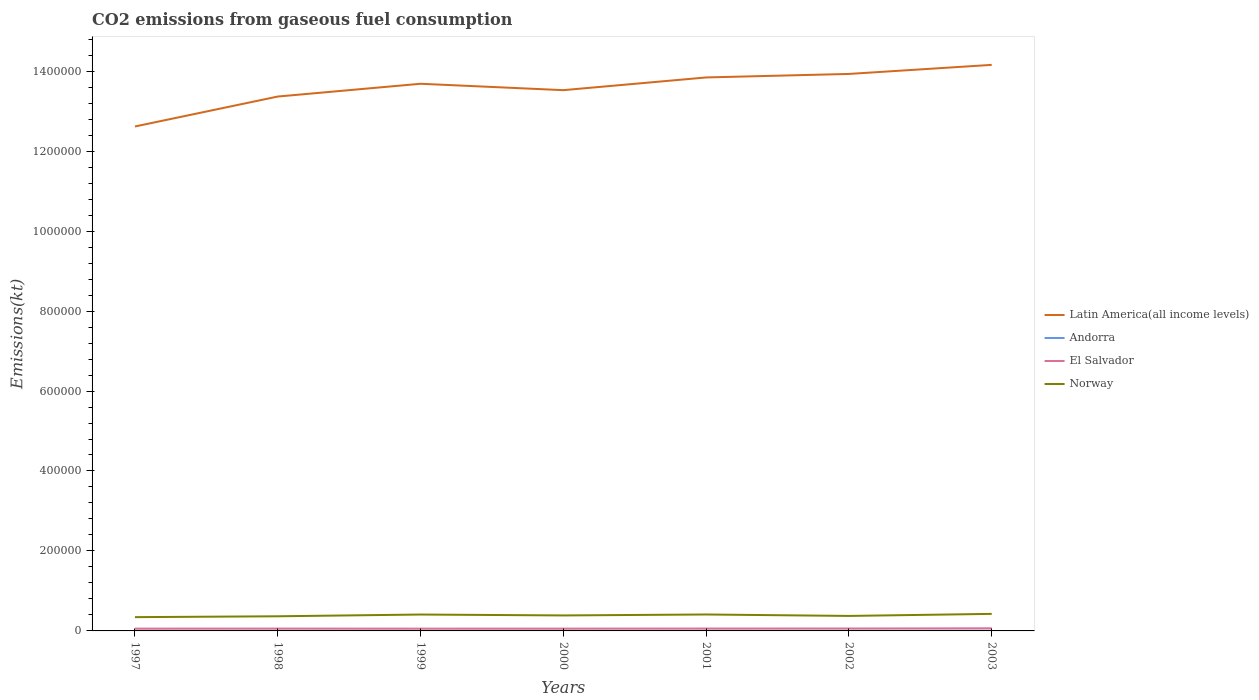Is the number of lines equal to the number of legend labels?
Your response must be concise. Yes. Across all years, what is the maximum amount of CO2 emitted in Norway?
Your response must be concise. 3.45e+04. What is the total amount of CO2 emitted in Latin America(all income levels) in the graph?
Offer a very short reply. -3.14e+04. What is the difference between the highest and the second highest amount of CO2 emitted in Norway?
Offer a terse response. 8166.41. What is the difference between the highest and the lowest amount of CO2 emitted in Latin America(all income levels)?
Your answer should be very brief. 4. How many years are there in the graph?
Ensure brevity in your answer.  7. What is the difference between two consecutive major ticks on the Y-axis?
Offer a terse response. 2.00e+05. Are the values on the major ticks of Y-axis written in scientific E-notation?
Provide a succinct answer. No. Does the graph contain grids?
Make the answer very short. No. What is the title of the graph?
Give a very brief answer. CO2 emissions from gaseous fuel consumption. Does "Netherlands" appear as one of the legend labels in the graph?
Give a very brief answer. No. What is the label or title of the Y-axis?
Give a very brief answer. Emissions(kt). What is the Emissions(kt) in Latin America(all income levels) in 1997?
Give a very brief answer. 1.26e+06. What is the Emissions(kt) in Andorra in 1997?
Ensure brevity in your answer.  458.38. What is the Emissions(kt) in El Salvador in 1997?
Give a very brief answer. 5760.86. What is the Emissions(kt) in Norway in 1997?
Provide a short and direct response. 3.45e+04. What is the Emissions(kt) of Latin America(all income levels) in 1998?
Provide a short and direct response. 1.34e+06. What is the Emissions(kt) in Andorra in 1998?
Keep it short and to the point. 484.04. What is the Emissions(kt) in El Salvador in 1998?
Offer a very short reply. 5812.19. What is the Emissions(kt) in Norway in 1998?
Give a very brief answer. 3.66e+04. What is the Emissions(kt) of Latin America(all income levels) in 1999?
Your response must be concise. 1.37e+06. What is the Emissions(kt) of Andorra in 1999?
Make the answer very short. 513.38. What is the Emissions(kt) of El Salvador in 1999?
Your response must be concise. 5698.52. What is the Emissions(kt) in Norway in 1999?
Provide a succinct answer. 4.10e+04. What is the Emissions(kt) of Latin America(all income levels) in 2000?
Give a very brief answer. 1.35e+06. What is the Emissions(kt) of Andorra in 2000?
Your response must be concise. 524.38. What is the Emissions(kt) of El Salvador in 2000?
Ensure brevity in your answer.  5742.52. What is the Emissions(kt) of Norway in 2000?
Keep it short and to the point. 3.87e+04. What is the Emissions(kt) in Latin America(all income levels) in 2001?
Your response must be concise. 1.38e+06. What is the Emissions(kt) of Andorra in 2001?
Offer a terse response. 524.38. What is the Emissions(kt) of El Salvador in 2001?
Give a very brief answer. 5947.87. What is the Emissions(kt) in Norway in 2001?
Your answer should be compact. 4.11e+04. What is the Emissions(kt) of Latin America(all income levels) in 2002?
Provide a short and direct response. 1.39e+06. What is the Emissions(kt) in Andorra in 2002?
Your answer should be compact. 531.72. What is the Emissions(kt) of El Salvador in 2002?
Make the answer very short. 6039.55. What is the Emissions(kt) of Norway in 2002?
Your answer should be very brief. 3.75e+04. What is the Emissions(kt) of Latin America(all income levels) in 2003?
Ensure brevity in your answer.  1.42e+06. What is the Emissions(kt) of Andorra in 2003?
Provide a short and direct response. 535.38. What is the Emissions(kt) of El Salvador in 2003?
Offer a terse response. 6552.93. What is the Emissions(kt) in Norway in 2003?
Provide a short and direct response. 4.26e+04. Across all years, what is the maximum Emissions(kt) of Latin America(all income levels)?
Keep it short and to the point. 1.42e+06. Across all years, what is the maximum Emissions(kt) in Andorra?
Ensure brevity in your answer.  535.38. Across all years, what is the maximum Emissions(kt) of El Salvador?
Provide a succinct answer. 6552.93. Across all years, what is the maximum Emissions(kt) in Norway?
Offer a very short reply. 4.26e+04. Across all years, what is the minimum Emissions(kt) in Latin America(all income levels)?
Your response must be concise. 1.26e+06. Across all years, what is the minimum Emissions(kt) in Andorra?
Make the answer very short. 458.38. Across all years, what is the minimum Emissions(kt) of El Salvador?
Your answer should be very brief. 5698.52. Across all years, what is the minimum Emissions(kt) of Norway?
Your answer should be compact. 3.45e+04. What is the total Emissions(kt) of Latin America(all income levels) in the graph?
Provide a succinct answer. 9.51e+06. What is the total Emissions(kt) in Andorra in the graph?
Your answer should be compact. 3571.66. What is the total Emissions(kt) in El Salvador in the graph?
Provide a succinct answer. 4.16e+04. What is the total Emissions(kt) of Norway in the graph?
Offer a very short reply. 2.72e+05. What is the difference between the Emissions(kt) in Latin America(all income levels) in 1997 and that in 1998?
Give a very brief answer. -7.49e+04. What is the difference between the Emissions(kt) in Andorra in 1997 and that in 1998?
Offer a very short reply. -25.67. What is the difference between the Emissions(kt) in El Salvador in 1997 and that in 1998?
Your answer should be compact. -51.34. What is the difference between the Emissions(kt) of Norway in 1997 and that in 1998?
Your answer should be compact. -2152.53. What is the difference between the Emissions(kt) of Latin America(all income levels) in 1997 and that in 1999?
Ensure brevity in your answer.  -1.07e+05. What is the difference between the Emissions(kt) in Andorra in 1997 and that in 1999?
Provide a succinct answer. -55.01. What is the difference between the Emissions(kt) of El Salvador in 1997 and that in 1999?
Ensure brevity in your answer.  62.34. What is the difference between the Emissions(kt) in Norway in 1997 and that in 1999?
Make the answer very short. -6512.59. What is the difference between the Emissions(kt) of Latin America(all income levels) in 1997 and that in 2000?
Give a very brief answer. -9.09e+04. What is the difference between the Emissions(kt) of Andorra in 1997 and that in 2000?
Your answer should be very brief. -66.01. What is the difference between the Emissions(kt) of El Salvador in 1997 and that in 2000?
Provide a succinct answer. 18.34. What is the difference between the Emissions(kt) in Norway in 1997 and that in 2000?
Provide a short and direct response. -4264.72. What is the difference between the Emissions(kt) of Latin America(all income levels) in 1997 and that in 2001?
Offer a very short reply. -1.23e+05. What is the difference between the Emissions(kt) in Andorra in 1997 and that in 2001?
Give a very brief answer. -66.01. What is the difference between the Emissions(kt) of El Salvador in 1997 and that in 2001?
Your answer should be compact. -187.02. What is the difference between the Emissions(kt) of Norway in 1997 and that in 2001?
Provide a short and direct response. -6662.94. What is the difference between the Emissions(kt) in Latin America(all income levels) in 1997 and that in 2002?
Provide a succinct answer. -1.31e+05. What is the difference between the Emissions(kt) of Andorra in 1997 and that in 2002?
Your answer should be very brief. -73.34. What is the difference between the Emissions(kt) in El Salvador in 1997 and that in 2002?
Provide a succinct answer. -278.69. What is the difference between the Emissions(kt) of Norway in 1997 and that in 2002?
Make the answer very short. -3028.94. What is the difference between the Emissions(kt) in Latin America(all income levels) in 1997 and that in 2003?
Offer a terse response. -1.54e+05. What is the difference between the Emissions(kt) in Andorra in 1997 and that in 2003?
Give a very brief answer. -77.01. What is the difference between the Emissions(kt) in El Salvador in 1997 and that in 2003?
Provide a short and direct response. -792.07. What is the difference between the Emissions(kt) in Norway in 1997 and that in 2003?
Give a very brief answer. -8166.41. What is the difference between the Emissions(kt) of Latin America(all income levels) in 1998 and that in 1999?
Your answer should be very brief. -3.19e+04. What is the difference between the Emissions(kt) of Andorra in 1998 and that in 1999?
Keep it short and to the point. -29.34. What is the difference between the Emissions(kt) in El Salvador in 1998 and that in 1999?
Give a very brief answer. 113.68. What is the difference between the Emissions(kt) of Norway in 1998 and that in 1999?
Provide a succinct answer. -4360.06. What is the difference between the Emissions(kt) in Latin America(all income levels) in 1998 and that in 2000?
Give a very brief answer. -1.60e+04. What is the difference between the Emissions(kt) in Andorra in 1998 and that in 2000?
Your answer should be compact. -40.34. What is the difference between the Emissions(kt) in El Salvador in 1998 and that in 2000?
Your answer should be very brief. 69.67. What is the difference between the Emissions(kt) of Norway in 1998 and that in 2000?
Keep it short and to the point. -2112.19. What is the difference between the Emissions(kt) in Latin America(all income levels) in 1998 and that in 2001?
Offer a terse response. -4.78e+04. What is the difference between the Emissions(kt) in Andorra in 1998 and that in 2001?
Your response must be concise. -40.34. What is the difference between the Emissions(kt) of El Salvador in 1998 and that in 2001?
Your response must be concise. -135.68. What is the difference between the Emissions(kt) in Norway in 1998 and that in 2001?
Ensure brevity in your answer.  -4510.41. What is the difference between the Emissions(kt) in Latin America(all income levels) in 1998 and that in 2002?
Offer a very short reply. -5.65e+04. What is the difference between the Emissions(kt) of Andorra in 1998 and that in 2002?
Your response must be concise. -47.67. What is the difference between the Emissions(kt) in El Salvador in 1998 and that in 2002?
Your answer should be very brief. -227.35. What is the difference between the Emissions(kt) of Norway in 1998 and that in 2002?
Give a very brief answer. -876.41. What is the difference between the Emissions(kt) of Latin America(all income levels) in 1998 and that in 2003?
Your answer should be very brief. -7.92e+04. What is the difference between the Emissions(kt) in Andorra in 1998 and that in 2003?
Offer a very short reply. -51.34. What is the difference between the Emissions(kt) of El Salvador in 1998 and that in 2003?
Offer a very short reply. -740.73. What is the difference between the Emissions(kt) in Norway in 1998 and that in 2003?
Give a very brief answer. -6013.88. What is the difference between the Emissions(kt) of Latin America(all income levels) in 1999 and that in 2000?
Offer a terse response. 1.60e+04. What is the difference between the Emissions(kt) in Andorra in 1999 and that in 2000?
Ensure brevity in your answer.  -11. What is the difference between the Emissions(kt) in El Salvador in 1999 and that in 2000?
Ensure brevity in your answer.  -44. What is the difference between the Emissions(kt) of Norway in 1999 and that in 2000?
Ensure brevity in your answer.  2247.87. What is the difference between the Emissions(kt) in Latin America(all income levels) in 1999 and that in 2001?
Offer a terse response. -1.58e+04. What is the difference between the Emissions(kt) of Andorra in 1999 and that in 2001?
Give a very brief answer. -11. What is the difference between the Emissions(kt) of El Salvador in 1999 and that in 2001?
Give a very brief answer. -249.36. What is the difference between the Emissions(kt) of Norway in 1999 and that in 2001?
Ensure brevity in your answer.  -150.35. What is the difference between the Emissions(kt) of Latin America(all income levels) in 1999 and that in 2002?
Offer a terse response. -2.46e+04. What is the difference between the Emissions(kt) of Andorra in 1999 and that in 2002?
Your answer should be very brief. -18.34. What is the difference between the Emissions(kt) of El Salvador in 1999 and that in 2002?
Your answer should be very brief. -341.03. What is the difference between the Emissions(kt) in Norway in 1999 and that in 2002?
Provide a short and direct response. 3483.65. What is the difference between the Emissions(kt) of Latin America(all income levels) in 1999 and that in 2003?
Offer a very short reply. -4.73e+04. What is the difference between the Emissions(kt) of Andorra in 1999 and that in 2003?
Your response must be concise. -22. What is the difference between the Emissions(kt) in El Salvador in 1999 and that in 2003?
Provide a succinct answer. -854.41. What is the difference between the Emissions(kt) of Norway in 1999 and that in 2003?
Your answer should be very brief. -1653.82. What is the difference between the Emissions(kt) of Latin America(all income levels) in 2000 and that in 2001?
Your answer should be very brief. -3.18e+04. What is the difference between the Emissions(kt) in El Salvador in 2000 and that in 2001?
Keep it short and to the point. -205.35. What is the difference between the Emissions(kt) in Norway in 2000 and that in 2001?
Provide a short and direct response. -2398.22. What is the difference between the Emissions(kt) of Latin America(all income levels) in 2000 and that in 2002?
Offer a terse response. -4.06e+04. What is the difference between the Emissions(kt) in Andorra in 2000 and that in 2002?
Your response must be concise. -7.33. What is the difference between the Emissions(kt) in El Salvador in 2000 and that in 2002?
Ensure brevity in your answer.  -297.03. What is the difference between the Emissions(kt) in Norway in 2000 and that in 2002?
Your answer should be very brief. 1235.78. What is the difference between the Emissions(kt) of Latin America(all income levels) in 2000 and that in 2003?
Provide a succinct answer. -6.32e+04. What is the difference between the Emissions(kt) in Andorra in 2000 and that in 2003?
Give a very brief answer. -11. What is the difference between the Emissions(kt) of El Salvador in 2000 and that in 2003?
Offer a very short reply. -810.41. What is the difference between the Emissions(kt) in Norway in 2000 and that in 2003?
Make the answer very short. -3901.69. What is the difference between the Emissions(kt) in Latin America(all income levels) in 2001 and that in 2002?
Ensure brevity in your answer.  -8783.15. What is the difference between the Emissions(kt) of Andorra in 2001 and that in 2002?
Provide a short and direct response. -7.33. What is the difference between the Emissions(kt) of El Salvador in 2001 and that in 2002?
Provide a succinct answer. -91.67. What is the difference between the Emissions(kt) of Norway in 2001 and that in 2002?
Your answer should be very brief. 3634. What is the difference between the Emissions(kt) of Latin America(all income levels) in 2001 and that in 2003?
Give a very brief answer. -3.14e+04. What is the difference between the Emissions(kt) of Andorra in 2001 and that in 2003?
Keep it short and to the point. -11. What is the difference between the Emissions(kt) of El Salvador in 2001 and that in 2003?
Make the answer very short. -605.05. What is the difference between the Emissions(kt) of Norway in 2001 and that in 2003?
Provide a succinct answer. -1503.47. What is the difference between the Emissions(kt) in Latin America(all income levels) in 2002 and that in 2003?
Ensure brevity in your answer.  -2.27e+04. What is the difference between the Emissions(kt) of Andorra in 2002 and that in 2003?
Ensure brevity in your answer.  -3.67. What is the difference between the Emissions(kt) in El Salvador in 2002 and that in 2003?
Ensure brevity in your answer.  -513.38. What is the difference between the Emissions(kt) in Norway in 2002 and that in 2003?
Make the answer very short. -5137.47. What is the difference between the Emissions(kt) in Latin America(all income levels) in 1997 and the Emissions(kt) in Andorra in 1998?
Make the answer very short. 1.26e+06. What is the difference between the Emissions(kt) in Latin America(all income levels) in 1997 and the Emissions(kt) in El Salvador in 1998?
Provide a short and direct response. 1.26e+06. What is the difference between the Emissions(kt) of Latin America(all income levels) in 1997 and the Emissions(kt) of Norway in 1998?
Offer a very short reply. 1.23e+06. What is the difference between the Emissions(kt) in Andorra in 1997 and the Emissions(kt) in El Salvador in 1998?
Your response must be concise. -5353.82. What is the difference between the Emissions(kt) of Andorra in 1997 and the Emissions(kt) of Norway in 1998?
Your answer should be compact. -3.62e+04. What is the difference between the Emissions(kt) in El Salvador in 1997 and the Emissions(kt) in Norway in 1998?
Your response must be concise. -3.09e+04. What is the difference between the Emissions(kt) in Latin America(all income levels) in 1997 and the Emissions(kt) in Andorra in 1999?
Give a very brief answer. 1.26e+06. What is the difference between the Emissions(kt) of Latin America(all income levels) in 1997 and the Emissions(kt) of El Salvador in 1999?
Keep it short and to the point. 1.26e+06. What is the difference between the Emissions(kt) in Latin America(all income levels) in 1997 and the Emissions(kt) in Norway in 1999?
Ensure brevity in your answer.  1.22e+06. What is the difference between the Emissions(kt) of Andorra in 1997 and the Emissions(kt) of El Salvador in 1999?
Offer a terse response. -5240.14. What is the difference between the Emissions(kt) of Andorra in 1997 and the Emissions(kt) of Norway in 1999?
Provide a succinct answer. -4.05e+04. What is the difference between the Emissions(kt) in El Salvador in 1997 and the Emissions(kt) in Norway in 1999?
Your answer should be compact. -3.52e+04. What is the difference between the Emissions(kt) of Latin America(all income levels) in 1997 and the Emissions(kt) of Andorra in 2000?
Offer a very short reply. 1.26e+06. What is the difference between the Emissions(kt) of Latin America(all income levels) in 1997 and the Emissions(kt) of El Salvador in 2000?
Your answer should be very brief. 1.26e+06. What is the difference between the Emissions(kt) of Latin America(all income levels) in 1997 and the Emissions(kt) of Norway in 2000?
Ensure brevity in your answer.  1.22e+06. What is the difference between the Emissions(kt) in Andorra in 1997 and the Emissions(kt) in El Salvador in 2000?
Make the answer very short. -5284.15. What is the difference between the Emissions(kt) in Andorra in 1997 and the Emissions(kt) in Norway in 2000?
Give a very brief answer. -3.83e+04. What is the difference between the Emissions(kt) of El Salvador in 1997 and the Emissions(kt) of Norway in 2000?
Ensure brevity in your answer.  -3.30e+04. What is the difference between the Emissions(kt) in Latin America(all income levels) in 1997 and the Emissions(kt) in Andorra in 2001?
Your answer should be compact. 1.26e+06. What is the difference between the Emissions(kt) of Latin America(all income levels) in 1997 and the Emissions(kt) of El Salvador in 2001?
Your response must be concise. 1.26e+06. What is the difference between the Emissions(kt) of Latin America(all income levels) in 1997 and the Emissions(kt) of Norway in 2001?
Provide a succinct answer. 1.22e+06. What is the difference between the Emissions(kt) in Andorra in 1997 and the Emissions(kt) in El Salvador in 2001?
Your answer should be compact. -5489.5. What is the difference between the Emissions(kt) in Andorra in 1997 and the Emissions(kt) in Norway in 2001?
Your answer should be very brief. -4.07e+04. What is the difference between the Emissions(kt) in El Salvador in 1997 and the Emissions(kt) in Norway in 2001?
Provide a succinct answer. -3.54e+04. What is the difference between the Emissions(kt) in Latin America(all income levels) in 1997 and the Emissions(kt) in Andorra in 2002?
Offer a very short reply. 1.26e+06. What is the difference between the Emissions(kt) of Latin America(all income levels) in 1997 and the Emissions(kt) of El Salvador in 2002?
Make the answer very short. 1.26e+06. What is the difference between the Emissions(kt) in Latin America(all income levels) in 1997 and the Emissions(kt) in Norway in 2002?
Offer a terse response. 1.22e+06. What is the difference between the Emissions(kt) in Andorra in 1997 and the Emissions(kt) in El Salvador in 2002?
Your answer should be very brief. -5581.17. What is the difference between the Emissions(kt) of Andorra in 1997 and the Emissions(kt) of Norway in 2002?
Provide a succinct answer. -3.70e+04. What is the difference between the Emissions(kt) in El Salvador in 1997 and the Emissions(kt) in Norway in 2002?
Your answer should be very brief. -3.17e+04. What is the difference between the Emissions(kt) of Latin America(all income levels) in 1997 and the Emissions(kt) of Andorra in 2003?
Offer a very short reply. 1.26e+06. What is the difference between the Emissions(kt) in Latin America(all income levels) in 1997 and the Emissions(kt) in El Salvador in 2003?
Provide a short and direct response. 1.26e+06. What is the difference between the Emissions(kt) in Latin America(all income levels) in 1997 and the Emissions(kt) in Norway in 2003?
Offer a very short reply. 1.22e+06. What is the difference between the Emissions(kt) in Andorra in 1997 and the Emissions(kt) in El Salvador in 2003?
Give a very brief answer. -6094.55. What is the difference between the Emissions(kt) in Andorra in 1997 and the Emissions(kt) in Norway in 2003?
Make the answer very short. -4.22e+04. What is the difference between the Emissions(kt) in El Salvador in 1997 and the Emissions(kt) in Norway in 2003?
Make the answer very short. -3.69e+04. What is the difference between the Emissions(kt) in Latin America(all income levels) in 1998 and the Emissions(kt) in Andorra in 1999?
Offer a terse response. 1.34e+06. What is the difference between the Emissions(kt) in Latin America(all income levels) in 1998 and the Emissions(kt) in El Salvador in 1999?
Ensure brevity in your answer.  1.33e+06. What is the difference between the Emissions(kt) in Latin America(all income levels) in 1998 and the Emissions(kt) in Norway in 1999?
Offer a terse response. 1.30e+06. What is the difference between the Emissions(kt) of Andorra in 1998 and the Emissions(kt) of El Salvador in 1999?
Provide a succinct answer. -5214.47. What is the difference between the Emissions(kt) in Andorra in 1998 and the Emissions(kt) in Norway in 1999?
Keep it short and to the point. -4.05e+04. What is the difference between the Emissions(kt) in El Salvador in 1998 and the Emissions(kt) in Norway in 1999?
Your answer should be compact. -3.52e+04. What is the difference between the Emissions(kt) in Latin America(all income levels) in 1998 and the Emissions(kt) in Andorra in 2000?
Your response must be concise. 1.34e+06. What is the difference between the Emissions(kt) of Latin America(all income levels) in 1998 and the Emissions(kt) of El Salvador in 2000?
Offer a very short reply. 1.33e+06. What is the difference between the Emissions(kt) in Latin America(all income levels) in 1998 and the Emissions(kt) in Norway in 2000?
Ensure brevity in your answer.  1.30e+06. What is the difference between the Emissions(kt) of Andorra in 1998 and the Emissions(kt) of El Salvador in 2000?
Ensure brevity in your answer.  -5258.48. What is the difference between the Emissions(kt) in Andorra in 1998 and the Emissions(kt) in Norway in 2000?
Ensure brevity in your answer.  -3.82e+04. What is the difference between the Emissions(kt) in El Salvador in 1998 and the Emissions(kt) in Norway in 2000?
Your response must be concise. -3.29e+04. What is the difference between the Emissions(kt) of Latin America(all income levels) in 1998 and the Emissions(kt) of Andorra in 2001?
Offer a very short reply. 1.34e+06. What is the difference between the Emissions(kt) in Latin America(all income levels) in 1998 and the Emissions(kt) in El Salvador in 2001?
Offer a terse response. 1.33e+06. What is the difference between the Emissions(kt) of Latin America(all income levels) in 1998 and the Emissions(kt) of Norway in 2001?
Offer a very short reply. 1.30e+06. What is the difference between the Emissions(kt) of Andorra in 1998 and the Emissions(kt) of El Salvador in 2001?
Give a very brief answer. -5463.83. What is the difference between the Emissions(kt) of Andorra in 1998 and the Emissions(kt) of Norway in 2001?
Offer a very short reply. -4.06e+04. What is the difference between the Emissions(kt) in El Salvador in 1998 and the Emissions(kt) in Norway in 2001?
Offer a very short reply. -3.53e+04. What is the difference between the Emissions(kt) in Latin America(all income levels) in 1998 and the Emissions(kt) in Andorra in 2002?
Provide a succinct answer. 1.34e+06. What is the difference between the Emissions(kt) in Latin America(all income levels) in 1998 and the Emissions(kt) in El Salvador in 2002?
Make the answer very short. 1.33e+06. What is the difference between the Emissions(kt) of Latin America(all income levels) in 1998 and the Emissions(kt) of Norway in 2002?
Provide a succinct answer. 1.30e+06. What is the difference between the Emissions(kt) of Andorra in 1998 and the Emissions(kt) of El Salvador in 2002?
Your answer should be compact. -5555.51. What is the difference between the Emissions(kt) of Andorra in 1998 and the Emissions(kt) of Norway in 2002?
Make the answer very short. -3.70e+04. What is the difference between the Emissions(kt) of El Salvador in 1998 and the Emissions(kt) of Norway in 2002?
Ensure brevity in your answer.  -3.17e+04. What is the difference between the Emissions(kt) of Latin America(all income levels) in 1998 and the Emissions(kt) of Andorra in 2003?
Provide a succinct answer. 1.34e+06. What is the difference between the Emissions(kt) in Latin America(all income levels) in 1998 and the Emissions(kt) in El Salvador in 2003?
Give a very brief answer. 1.33e+06. What is the difference between the Emissions(kt) in Latin America(all income levels) in 1998 and the Emissions(kt) in Norway in 2003?
Give a very brief answer. 1.29e+06. What is the difference between the Emissions(kt) in Andorra in 1998 and the Emissions(kt) in El Salvador in 2003?
Your response must be concise. -6068.89. What is the difference between the Emissions(kt) of Andorra in 1998 and the Emissions(kt) of Norway in 2003?
Your answer should be very brief. -4.21e+04. What is the difference between the Emissions(kt) of El Salvador in 1998 and the Emissions(kt) of Norway in 2003?
Provide a succinct answer. -3.68e+04. What is the difference between the Emissions(kt) in Latin America(all income levels) in 1999 and the Emissions(kt) in Andorra in 2000?
Give a very brief answer. 1.37e+06. What is the difference between the Emissions(kt) of Latin America(all income levels) in 1999 and the Emissions(kt) of El Salvador in 2000?
Give a very brief answer. 1.36e+06. What is the difference between the Emissions(kt) in Latin America(all income levels) in 1999 and the Emissions(kt) in Norway in 2000?
Provide a short and direct response. 1.33e+06. What is the difference between the Emissions(kt) of Andorra in 1999 and the Emissions(kt) of El Salvador in 2000?
Your answer should be very brief. -5229.14. What is the difference between the Emissions(kt) in Andorra in 1999 and the Emissions(kt) in Norway in 2000?
Offer a very short reply. -3.82e+04. What is the difference between the Emissions(kt) of El Salvador in 1999 and the Emissions(kt) of Norway in 2000?
Give a very brief answer. -3.30e+04. What is the difference between the Emissions(kt) in Latin America(all income levels) in 1999 and the Emissions(kt) in Andorra in 2001?
Keep it short and to the point. 1.37e+06. What is the difference between the Emissions(kt) of Latin America(all income levels) in 1999 and the Emissions(kt) of El Salvador in 2001?
Ensure brevity in your answer.  1.36e+06. What is the difference between the Emissions(kt) in Latin America(all income levels) in 1999 and the Emissions(kt) in Norway in 2001?
Provide a short and direct response. 1.33e+06. What is the difference between the Emissions(kt) of Andorra in 1999 and the Emissions(kt) of El Salvador in 2001?
Offer a very short reply. -5434.49. What is the difference between the Emissions(kt) of Andorra in 1999 and the Emissions(kt) of Norway in 2001?
Keep it short and to the point. -4.06e+04. What is the difference between the Emissions(kt) in El Salvador in 1999 and the Emissions(kt) in Norway in 2001?
Provide a succinct answer. -3.54e+04. What is the difference between the Emissions(kt) in Latin America(all income levels) in 1999 and the Emissions(kt) in Andorra in 2002?
Provide a succinct answer. 1.37e+06. What is the difference between the Emissions(kt) of Latin America(all income levels) in 1999 and the Emissions(kt) of El Salvador in 2002?
Give a very brief answer. 1.36e+06. What is the difference between the Emissions(kt) of Latin America(all income levels) in 1999 and the Emissions(kt) of Norway in 2002?
Offer a terse response. 1.33e+06. What is the difference between the Emissions(kt) in Andorra in 1999 and the Emissions(kt) in El Salvador in 2002?
Provide a succinct answer. -5526.17. What is the difference between the Emissions(kt) of Andorra in 1999 and the Emissions(kt) of Norway in 2002?
Make the answer very short. -3.70e+04. What is the difference between the Emissions(kt) in El Salvador in 1999 and the Emissions(kt) in Norway in 2002?
Give a very brief answer. -3.18e+04. What is the difference between the Emissions(kt) of Latin America(all income levels) in 1999 and the Emissions(kt) of Andorra in 2003?
Keep it short and to the point. 1.37e+06. What is the difference between the Emissions(kt) in Latin America(all income levels) in 1999 and the Emissions(kt) in El Salvador in 2003?
Your answer should be compact. 1.36e+06. What is the difference between the Emissions(kt) of Latin America(all income levels) in 1999 and the Emissions(kt) of Norway in 2003?
Ensure brevity in your answer.  1.33e+06. What is the difference between the Emissions(kt) in Andorra in 1999 and the Emissions(kt) in El Salvador in 2003?
Offer a very short reply. -6039.55. What is the difference between the Emissions(kt) in Andorra in 1999 and the Emissions(kt) in Norway in 2003?
Give a very brief answer. -4.21e+04. What is the difference between the Emissions(kt) in El Salvador in 1999 and the Emissions(kt) in Norway in 2003?
Your response must be concise. -3.69e+04. What is the difference between the Emissions(kt) in Latin America(all income levels) in 2000 and the Emissions(kt) in Andorra in 2001?
Give a very brief answer. 1.35e+06. What is the difference between the Emissions(kt) in Latin America(all income levels) in 2000 and the Emissions(kt) in El Salvador in 2001?
Your response must be concise. 1.35e+06. What is the difference between the Emissions(kt) of Latin America(all income levels) in 2000 and the Emissions(kt) of Norway in 2001?
Your response must be concise. 1.31e+06. What is the difference between the Emissions(kt) in Andorra in 2000 and the Emissions(kt) in El Salvador in 2001?
Offer a very short reply. -5423.49. What is the difference between the Emissions(kt) in Andorra in 2000 and the Emissions(kt) in Norway in 2001?
Your answer should be very brief. -4.06e+04. What is the difference between the Emissions(kt) in El Salvador in 2000 and the Emissions(kt) in Norway in 2001?
Keep it short and to the point. -3.54e+04. What is the difference between the Emissions(kt) in Latin America(all income levels) in 2000 and the Emissions(kt) in Andorra in 2002?
Provide a succinct answer. 1.35e+06. What is the difference between the Emissions(kt) of Latin America(all income levels) in 2000 and the Emissions(kt) of El Salvador in 2002?
Keep it short and to the point. 1.35e+06. What is the difference between the Emissions(kt) in Latin America(all income levels) in 2000 and the Emissions(kt) in Norway in 2002?
Offer a very short reply. 1.32e+06. What is the difference between the Emissions(kt) of Andorra in 2000 and the Emissions(kt) of El Salvador in 2002?
Give a very brief answer. -5515.17. What is the difference between the Emissions(kt) in Andorra in 2000 and the Emissions(kt) in Norway in 2002?
Provide a succinct answer. -3.70e+04. What is the difference between the Emissions(kt) of El Salvador in 2000 and the Emissions(kt) of Norway in 2002?
Your response must be concise. -3.18e+04. What is the difference between the Emissions(kt) of Latin America(all income levels) in 2000 and the Emissions(kt) of Andorra in 2003?
Provide a succinct answer. 1.35e+06. What is the difference between the Emissions(kt) in Latin America(all income levels) in 2000 and the Emissions(kt) in El Salvador in 2003?
Give a very brief answer. 1.35e+06. What is the difference between the Emissions(kt) in Latin America(all income levels) in 2000 and the Emissions(kt) in Norway in 2003?
Your answer should be very brief. 1.31e+06. What is the difference between the Emissions(kt) of Andorra in 2000 and the Emissions(kt) of El Salvador in 2003?
Offer a terse response. -6028.55. What is the difference between the Emissions(kt) in Andorra in 2000 and the Emissions(kt) in Norway in 2003?
Ensure brevity in your answer.  -4.21e+04. What is the difference between the Emissions(kt) of El Salvador in 2000 and the Emissions(kt) of Norway in 2003?
Give a very brief answer. -3.69e+04. What is the difference between the Emissions(kt) in Latin America(all income levels) in 2001 and the Emissions(kt) in Andorra in 2002?
Your answer should be very brief. 1.38e+06. What is the difference between the Emissions(kt) of Latin America(all income levels) in 2001 and the Emissions(kt) of El Salvador in 2002?
Offer a very short reply. 1.38e+06. What is the difference between the Emissions(kt) in Latin America(all income levels) in 2001 and the Emissions(kt) in Norway in 2002?
Your response must be concise. 1.35e+06. What is the difference between the Emissions(kt) of Andorra in 2001 and the Emissions(kt) of El Salvador in 2002?
Your response must be concise. -5515.17. What is the difference between the Emissions(kt) of Andorra in 2001 and the Emissions(kt) of Norway in 2002?
Your answer should be very brief. -3.70e+04. What is the difference between the Emissions(kt) in El Salvador in 2001 and the Emissions(kt) in Norway in 2002?
Provide a short and direct response. -3.15e+04. What is the difference between the Emissions(kt) of Latin America(all income levels) in 2001 and the Emissions(kt) of Andorra in 2003?
Your response must be concise. 1.38e+06. What is the difference between the Emissions(kt) of Latin America(all income levels) in 2001 and the Emissions(kt) of El Salvador in 2003?
Give a very brief answer. 1.38e+06. What is the difference between the Emissions(kt) in Latin America(all income levels) in 2001 and the Emissions(kt) in Norway in 2003?
Keep it short and to the point. 1.34e+06. What is the difference between the Emissions(kt) of Andorra in 2001 and the Emissions(kt) of El Salvador in 2003?
Offer a very short reply. -6028.55. What is the difference between the Emissions(kt) of Andorra in 2001 and the Emissions(kt) of Norway in 2003?
Offer a very short reply. -4.21e+04. What is the difference between the Emissions(kt) of El Salvador in 2001 and the Emissions(kt) of Norway in 2003?
Your answer should be compact. -3.67e+04. What is the difference between the Emissions(kt) in Latin America(all income levels) in 2002 and the Emissions(kt) in Andorra in 2003?
Offer a terse response. 1.39e+06. What is the difference between the Emissions(kt) of Latin America(all income levels) in 2002 and the Emissions(kt) of El Salvador in 2003?
Provide a succinct answer. 1.39e+06. What is the difference between the Emissions(kt) in Latin America(all income levels) in 2002 and the Emissions(kt) in Norway in 2003?
Provide a succinct answer. 1.35e+06. What is the difference between the Emissions(kt) in Andorra in 2002 and the Emissions(kt) in El Salvador in 2003?
Your answer should be very brief. -6021.21. What is the difference between the Emissions(kt) of Andorra in 2002 and the Emissions(kt) of Norway in 2003?
Offer a very short reply. -4.21e+04. What is the difference between the Emissions(kt) in El Salvador in 2002 and the Emissions(kt) in Norway in 2003?
Offer a terse response. -3.66e+04. What is the average Emissions(kt) in Latin America(all income levels) per year?
Offer a very short reply. 1.36e+06. What is the average Emissions(kt) in Andorra per year?
Your answer should be compact. 510.24. What is the average Emissions(kt) in El Salvador per year?
Provide a short and direct response. 5936.35. What is the average Emissions(kt) of Norway per year?
Offer a terse response. 3.89e+04. In the year 1997, what is the difference between the Emissions(kt) of Latin America(all income levels) and Emissions(kt) of Andorra?
Ensure brevity in your answer.  1.26e+06. In the year 1997, what is the difference between the Emissions(kt) of Latin America(all income levels) and Emissions(kt) of El Salvador?
Ensure brevity in your answer.  1.26e+06. In the year 1997, what is the difference between the Emissions(kt) in Latin America(all income levels) and Emissions(kt) in Norway?
Provide a succinct answer. 1.23e+06. In the year 1997, what is the difference between the Emissions(kt) of Andorra and Emissions(kt) of El Salvador?
Provide a succinct answer. -5302.48. In the year 1997, what is the difference between the Emissions(kt) of Andorra and Emissions(kt) of Norway?
Provide a short and direct response. -3.40e+04. In the year 1997, what is the difference between the Emissions(kt) of El Salvador and Emissions(kt) of Norway?
Your answer should be compact. -2.87e+04. In the year 1998, what is the difference between the Emissions(kt) in Latin America(all income levels) and Emissions(kt) in Andorra?
Make the answer very short. 1.34e+06. In the year 1998, what is the difference between the Emissions(kt) in Latin America(all income levels) and Emissions(kt) in El Salvador?
Provide a succinct answer. 1.33e+06. In the year 1998, what is the difference between the Emissions(kt) in Latin America(all income levels) and Emissions(kt) in Norway?
Offer a terse response. 1.30e+06. In the year 1998, what is the difference between the Emissions(kt) in Andorra and Emissions(kt) in El Salvador?
Give a very brief answer. -5328.15. In the year 1998, what is the difference between the Emissions(kt) in Andorra and Emissions(kt) in Norway?
Your answer should be very brief. -3.61e+04. In the year 1998, what is the difference between the Emissions(kt) in El Salvador and Emissions(kt) in Norway?
Provide a short and direct response. -3.08e+04. In the year 1999, what is the difference between the Emissions(kt) of Latin America(all income levels) and Emissions(kt) of Andorra?
Keep it short and to the point. 1.37e+06. In the year 1999, what is the difference between the Emissions(kt) of Latin America(all income levels) and Emissions(kt) of El Salvador?
Offer a terse response. 1.36e+06. In the year 1999, what is the difference between the Emissions(kt) of Latin America(all income levels) and Emissions(kt) of Norway?
Provide a succinct answer. 1.33e+06. In the year 1999, what is the difference between the Emissions(kt) of Andorra and Emissions(kt) of El Salvador?
Provide a short and direct response. -5185.14. In the year 1999, what is the difference between the Emissions(kt) in Andorra and Emissions(kt) in Norway?
Provide a short and direct response. -4.05e+04. In the year 1999, what is the difference between the Emissions(kt) of El Salvador and Emissions(kt) of Norway?
Your answer should be compact. -3.53e+04. In the year 2000, what is the difference between the Emissions(kt) of Latin America(all income levels) and Emissions(kt) of Andorra?
Give a very brief answer. 1.35e+06. In the year 2000, what is the difference between the Emissions(kt) in Latin America(all income levels) and Emissions(kt) in El Salvador?
Offer a terse response. 1.35e+06. In the year 2000, what is the difference between the Emissions(kt) in Latin America(all income levels) and Emissions(kt) in Norway?
Ensure brevity in your answer.  1.31e+06. In the year 2000, what is the difference between the Emissions(kt) of Andorra and Emissions(kt) of El Salvador?
Offer a terse response. -5218.14. In the year 2000, what is the difference between the Emissions(kt) in Andorra and Emissions(kt) in Norway?
Give a very brief answer. -3.82e+04. In the year 2000, what is the difference between the Emissions(kt) in El Salvador and Emissions(kt) in Norway?
Your answer should be very brief. -3.30e+04. In the year 2001, what is the difference between the Emissions(kt) of Latin America(all income levels) and Emissions(kt) of Andorra?
Keep it short and to the point. 1.38e+06. In the year 2001, what is the difference between the Emissions(kt) of Latin America(all income levels) and Emissions(kt) of El Salvador?
Your answer should be compact. 1.38e+06. In the year 2001, what is the difference between the Emissions(kt) in Latin America(all income levels) and Emissions(kt) in Norway?
Offer a terse response. 1.34e+06. In the year 2001, what is the difference between the Emissions(kt) in Andorra and Emissions(kt) in El Salvador?
Your answer should be very brief. -5423.49. In the year 2001, what is the difference between the Emissions(kt) in Andorra and Emissions(kt) in Norway?
Provide a succinct answer. -4.06e+04. In the year 2001, what is the difference between the Emissions(kt) in El Salvador and Emissions(kt) in Norway?
Offer a very short reply. -3.52e+04. In the year 2002, what is the difference between the Emissions(kt) in Latin America(all income levels) and Emissions(kt) in Andorra?
Ensure brevity in your answer.  1.39e+06. In the year 2002, what is the difference between the Emissions(kt) of Latin America(all income levels) and Emissions(kt) of El Salvador?
Ensure brevity in your answer.  1.39e+06. In the year 2002, what is the difference between the Emissions(kt) of Latin America(all income levels) and Emissions(kt) of Norway?
Provide a short and direct response. 1.36e+06. In the year 2002, what is the difference between the Emissions(kt) in Andorra and Emissions(kt) in El Salvador?
Give a very brief answer. -5507.83. In the year 2002, what is the difference between the Emissions(kt) in Andorra and Emissions(kt) in Norway?
Offer a very short reply. -3.70e+04. In the year 2002, what is the difference between the Emissions(kt) in El Salvador and Emissions(kt) in Norway?
Your answer should be compact. -3.15e+04. In the year 2003, what is the difference between the Emissions(kt) of Latin America(all income levels) and Emissions(kt) of Andorra?
Provide a short and direct response. 1.42e+06. In the year 2003, what is the difference between the Emissions(kt) in Latin America(all income levels) and Emissions(kt) in El Salvador?
Your answer should be very brief. 1.41e+06. In the year 2003, what is the difference between the Emissions(kt) in Latin America(all income levels) and Emissions(kt) in Norway?
Your answer should be compact. 1.37e+06. In the year 2003, what is the difference between the Emissions(kt) of Andorra and Emissions(kt) of El Salvador?
Your response must be concise. -6017.55. In the year 2003, what is the difference between the Emissions(kt) in Andorra and Emissions(kt) in Norway?
Provide a short and direct response. -4.21e+04. In the year 2003, what is the difference between the Emissions(kt) of El Salvador and Emissions(kt) of Norway?
Keep it short and to the point. -3.61e+04. What is the ratio of the Emissions(kt) in Latin America(all income levels) in 1997 to that in 1998?
Offer a terse response. 0.94. What is the ratio of the Emissions(kt) in Andorra in 1997 to that in 1998?
Provide a succinct answer. 0.95. What is the ratio of the Emissions(kt) in El Salvador in 1997 to that in 1998?
Give a very brief answer. 0.99. What is the ratio of the Emissions(kt) in Norway in 1997 to that in 1998?
Keep it short and to the point. 0.94. What is the ratio of the Emissions(kt) of Latin America(all income levels) in 1997 to that in 1999?
Your answer should be very brief. 0.92. What is the ratio of the Emissions(kt) in Andorra in 1997 to that in 1999?
Offer a very short reply. 0.89. What is the ratio of the Emissions(kt) in El Salvador in 1997 to that in 1999?
Your answer should be very brief. 1.01. What is the ratio of the Emissions(kt) of Norway in 1997 to that in 1999?
Your response must be concise. 0.84. What is the ratio of the Emissions(kt) in Latin America(all income levels) in 1997 to that in 2000?
Ensure brevity in your answer.  0.93. What is the ratio of the Emissions(kt) of Andorra in 1997 to that in 2000?
Offer a terse response. 0.87. What is the ratio of the Emissions(kt) in El Salvador in 1997 to that in 2000?
Provide a short and direct response. 1. What is the ratio of the Emissions(kt) of Norway in 1997 to that in 2000?
Ensure brevity in your answer.  0.89. What is the ratio of the Emissions(kt) of Latin America(all income levels) in 1997 to that in 2001?
Provide a succinct answer. 0.91. What is the ratio of the Emissions(kt) in Andorra in 1997 to that in 2001?
Your response must be concise. 0.87. What is the ratio of the Emissions(kt) in El Salvador in 1997 to that in 2001?
Offer a terse response. 0.97. What is the ratio of the Emissions(kt) of Norway in 1997 to that in 2001?
Provide a short and direct response. 0.84. What is the ratio of the Emissions(kt) of Latin America(all income levels) in 1997 to that in 2002?
Provide a succinct answer. 0.91. What is the ratio of the Emissions(kt) in Andorra in 1997 to that in 2002?
Your answer should be very brief. 0.86. What is the ratio of the Emissions(kt) of El Salvador in 1997 to that in 2002?
Your answer should be very brief. 0.95. What is the ratio of the Emissions(kt) in Norway in 1997 to that in 2002?
Provide a succinct answer. 0.92. What is the ratio of the Emissions(kt) in Latin America(all income levels) in 1997 to that in 2003?
Your answer should be compact. 0.89. What is the ratio of the Emissions(kt) in Andorra in 1997 to that in 2003?
Your answer should be compact. 0.86. What is the ratio of the Emissions(kt) of El Salvador in 1997 to that in 2003?
Ensure brevity in your answer.  0.88. What is the ratio of the Emissions(kt) of Norway in 1997 to that in 2003?
Keep it short and to the point. 0.81. What is the ratio of the Emissions(kt) of Latin America(all income levels) in 1998 to that in 1999?
Keep it short and to the point. 0.98. What is the ratio of the Emissions(kt) in Andorra in 1998 to that in 1999?
Offer a very short reply. 0.94. What is the ratio of the Emissions(kt) in El Salvador in 1998 to that in 1999?
Your answer should be compact. 1.02. What is the ratio of the Emissions(kt) of Norway in 1998 to that in 1999?
Offer a terse response. 0.89. What is the ratio of the Emissions(kt) of Andorra in 1998 to that in 2000?
Make the answer very short. 0.92. What is the ratio of the Emissions(kt) of El Salvador in 1998 to that in 2000?
Provide a succinct answer. 1.01. What is the ratio of the Emissions(kt) of Norway in 1998 to that in 2000?
Ensure brevity in your answer.  0.95. What is the ratio of the Emissions(kt) in Latin America(all income levels) in 1998 to that in 2001?
Offer a terse response. 0.97. What is the ratio of the Emissions(kt) in El Salvador in 1998 to that in 2001?
Give a very brief answer. 0.98. What is the ratio of the Emissions(kt) in Norway in 1998 to that in 2001?
Keep it short and to the point. 0.89. What is the ratio of the Emissions(kt) in Latin America(all income levels) in 1998 to that in 2002?
Keep it short and to the point. 0.96. What is the ratio of the Emissions(kt) of Andorra in 1998 to that in 2002?
Ensure brevity in your answer.  0.91. What is the ratio of the Emissions(kt) in El Salvador in 1998 to that in 2002?
Make the answer very short. 0.96. What is the ratio of the Emissions(kt) of Norway in 1998 to that in 2002?
Keep it short and to the point. 0.98. What is the ratio of the Emissions(kt) in Latin America(all income levels) in 1998 to that in 2003?
Offer a terse response. 0.94. What is the ratio of the Emissions(kt) of Andorra in 1998 to that in 2003?
Your answer should be very brief. 0.9. What is the ratio of the Emissions(kt) in El Salvador in 1998 to that in 2003?
Your response must be concise. 0.89. What is the ratio of the Emissions(kt) of Norway in 1998 to that in 2003?
Your response must be concise. 0.86. What is the ratio of the Emissions(kt) in Latin America(all income levels) in 1999 to that in 2000?
Your response must be concise. 1.01. What is the ratio of the Emissions(kt) in Andorra in 1999 to that in 2000?
Provide a succinct answer. 0.98. What is the ratio of the Emissions(kt) of El Salvador in 1999 to that in 2000?
Ensure brevity in your answer.  0.99. What is the ratio of the Emissions(kt) in Norway in 1999 to that in 2000?
Offer a terse response. 1.06. What is the ratio of the Emissions(kt) in Latin America(all income levels) in 1999 to that in 2001?
Give a very brief answer. 0.99. What is the ratio of the Emissions(kt) of Andorra in 1999 to that in 2001?
Make the answer very short. 0.98. What is the ratio of the Emissions(kt) in El Salvador in 1999 to that in 2001?
Provide a short and direct response. 0.96. What is the ratio of the Emissions(kt) in Norway in 1999 to that in 2001?
Provide a succinct answer. 1. What is the ratio of the Emissions(kt) in Latin America(all income levels) in 1999 to that in 2002?
Make the answer very short. 0.98. What is the ratio of the Emissions(kt) of Andorra in 1999 to that in 2002?
Give a very brief answer. 0.97. What is the ratio of the Emissions(kt) of El Salvador in 1999 to that in 2002?
Offer a very short reply. 0.94. What is the ratio of the Emissions(kt) of Norway in 1999 to that in 2002?
Offer a very short reply. 1.09. What is the ratio of the Emissions(kt) of Latin America(all income levels) in 1999 to that in 2003?
Your response must be concise. 0.97. What is the ratio of the Emissions(kt) of Andorra in 1999 to that in 2003?
Your answer should be compact. 0.96. What is the ratio of the Emissions(kt) of El Salvador in 1999 to that in 2003?
Keep it short and to the point. 0.87. What is the ratio of the Emissions(kt) of Norway in 1999 to that in 2003?
Ensure brevity in your answer.  0.96. What is the ratio of the Emissions(kt) of Latin America(all income levels) in 2000 to that in 2001?
Your answer should be compact. 0.98. What is the ratio of the Emissions(kt) in Andorra in 2000 to that in 2001?
Keep it short and to the point. 1. What is the ratio of the Emissions(kt) in El Salvador in 2000 to that in 2001?
Provide a short and direct response. 0.97. What is the ratio of the Emissions(kt) of Norway in 2000 to that in 2001?
Your answer should be compact. 0.94. What is the ratio of the Emissions(kt) of Latin America(all income levels) in 2000 to that in 2002?
Ensure brevity in your answer.  0.97. What is the ratio of the Emissions(kt) of Andorra in 2000 to that in 2002?
Provide a succinct answer. 0.99. What is the ratio of the Emissions(kt) in El Salvador in 2000 to that in 2002?
Offer a very short reply. 0.95. What is the ratio of the Emissions(kt) of Norway in 2000 to that in 2002?
Your answer should be compact. 1.03. What is the ratio of the Emissions(kt) of Latin America(all income levels) in 2000 to that in 2003?
Your response must be concise. 0.96. What is the ratio of the Emissions(kt) of Andorra in 2000 to that in 2003?
Your answer should be compact. 0.98. What is the ratio of the Emissions(kt) in El Salvador in 2000 to that in 2003?
Ensure brevity in your answer.  0.88. What is the ratio of the Emissions(kt) of Norway in 2000 to that in 2003?
Give a very brief answer. 0.91. What is the ratio of the Emissions(kt) in Andorra in 2001 to that in 2002?
Your response must be concise. 0.99. What is the ratio of the Emissions(kt) of El Salvador in 2001 to that in 2002?
Keep it short and to the point. 0.98. What is the ratio of the Emissions(kt) in Norway in 2001 to that in 2002?
Your answer should be compact. 1.1. What is the ratio of the Emissions(kt) of Latin America(all income levels) in 2001 to that in 2003?
Your answer should be compact. 0.98. What is the ratio of the Emissions(kt) of Andorra in 2001 to that in 2003?
Provide a succinct answer. 0.98. What is the ratio of the Emissions(kt) in El Salvador in 2001 to that in 2003?
Keep it short and to the point. 0.91. What is the ratio of the Emissions(kt) in Norway in 2001 to that in 2003?
Ensure brevity in your answer.  0.96. What is the ratio of the Emissions(kt) in Andorra in 2002 to that in 2003?
Your response must be concise. 0.99. What is the ratio of the Emissions(kt) in El Salvador in 2002 to that in 2003?
Your response must be concise. 0.92. What is the ratio of the Emissions(kt) in Norway in 2002 to that in 2003?
Provide a succinct answer. 0.88. What is the difference between the highest and the second highest Emissions(kt) of Latin America(all income levels)?
Give a very brief answer. 2.27e+04. What is the difference between the highest and the second highest Emissions(kt) in Andorra?
Provide a short and direct response. 3.67. What is the difference between the highest and the second highest Emissions(kt) in El Salvador?
Offer a very short reply. 513.38. What is the difference between the highest and the second highest Emissions(kt) in Norway?
Make the answer very short. 1503.47. What is the difference between the highest and the lowest Emissions(kt) in Latin America(all income levels)?
Make the answer very short. 1.54e+05. What is the difference between the highest and the lowest Emissions(kt) of Andorra?
Make the answer very short. 77.01. What is the difference between the highest and the lowest Emissions(kt) of El Salvador?
Offer a very short reply. 854.41. What is the difference between the highest and the lowest Emissions(kt) in Norway?
Provide a succinct answer. 8166.41. 